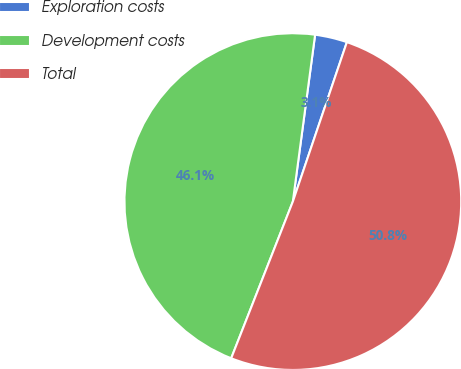Convert chart to OTSL. <chart><loc_0><loc_0><loc_500><loc_500><pie_chart><fcel>Exploration costs<fcel>Development costs<fcel>Total<nl><fcel>3.09%<fcel>46.15%<fcel>50.77%<nl></chart> 